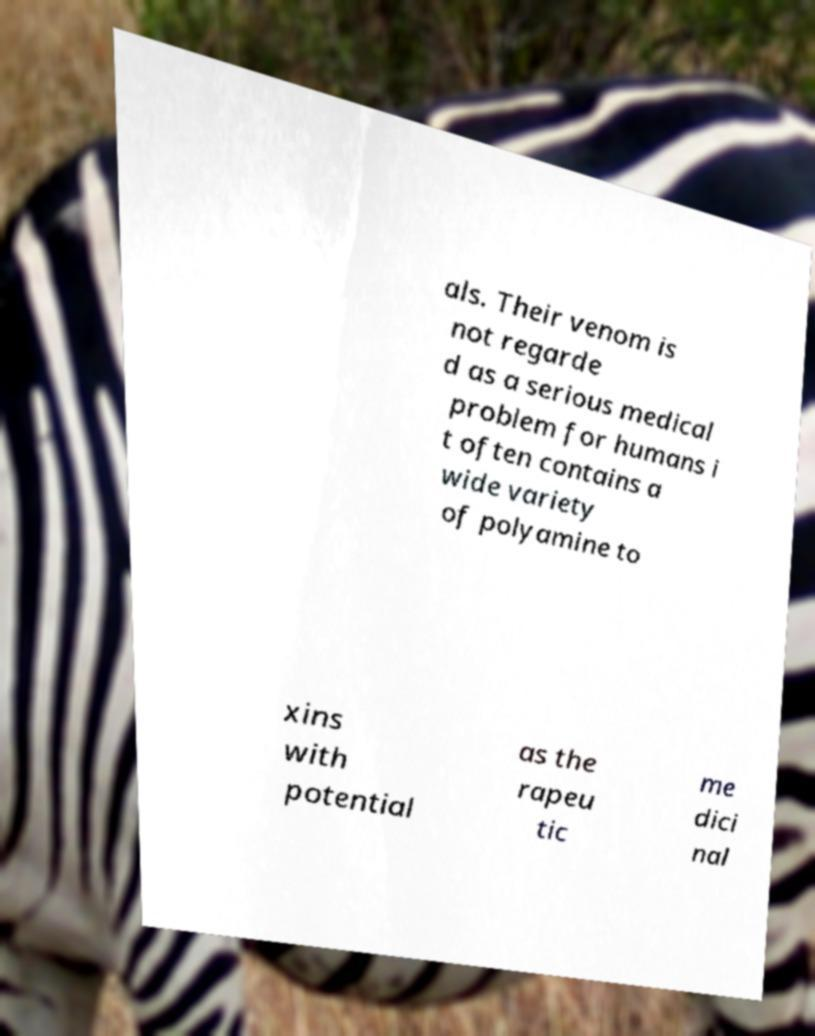Please identify and transcribe the text found in this image. als. Their venom is not regarde d as a serious medical problem for humans i t often contains a wide variety of polyamine to xins with potential as the rapeu tic me dici nal 